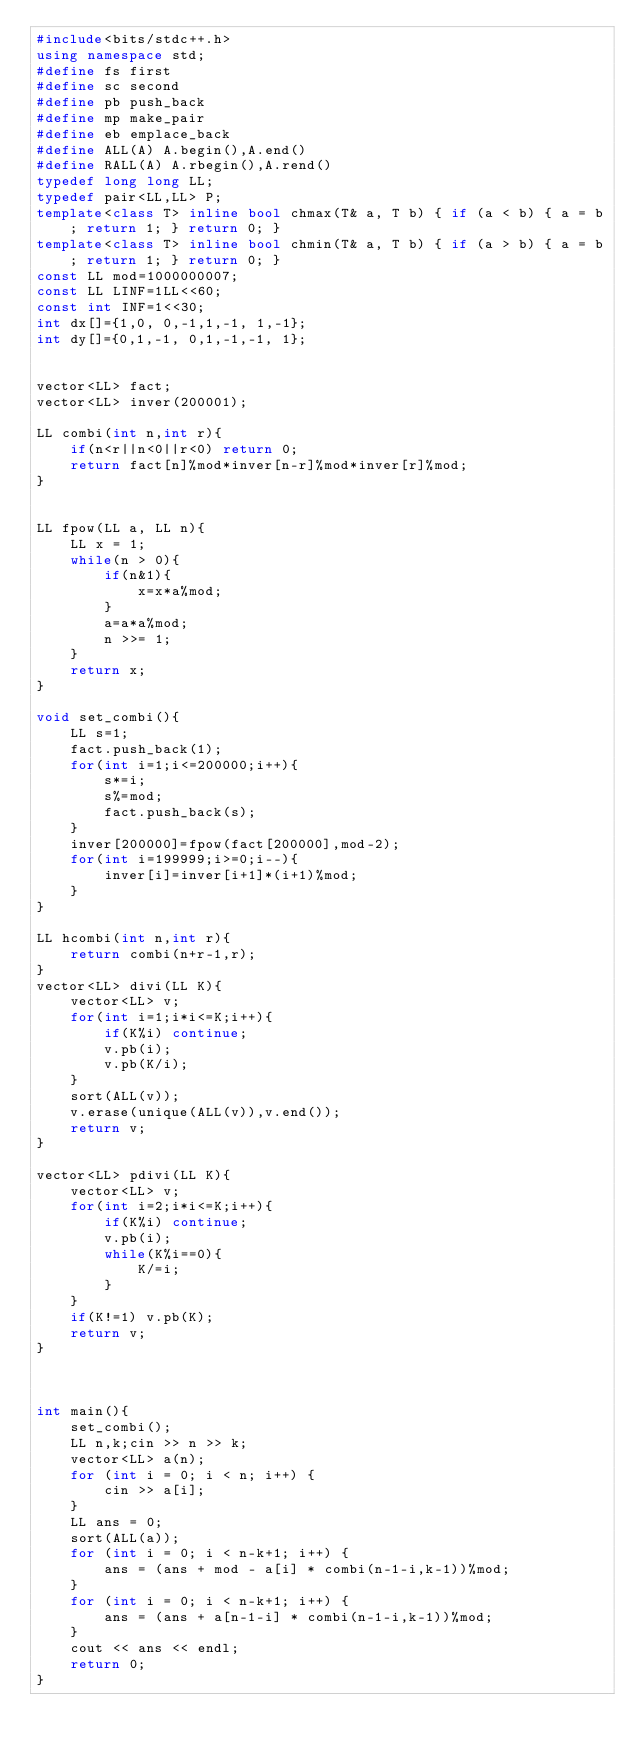<code> <loc_0><loc_0><loc_500><loc_500><_C++_>#include<bits/stdc++.h>
using namespace std;
#define fs first
#define sc second
#define pb push_back
#define mp make_pair
#define eb emplace_back
#define ALL(A) A.begin(),A.end()
#define RALL(A) A.rbegin(),A.rend()
typedef long long LL;
typedef pair<LL,LL> P;
template<class T> inline bool chmax(T& a, T b) { if (a < b) { a = b; return 1; } return 0; }
template<class T> inline bool chmin(T& a, T b) { if (a > b) { a = b; return 1; } return 0; }
const LL mod=1000000007;
const LL LINF=1LL<<60;
const int INF=1<<30;
int dx[]={1,0, 0,-1,1,-1, 1,-1};
int dy[]={0,1,-1, 0,1,-1,-1, 1};

 
vector<LL> fact;
vector<LL> inver(200001);
 
LL combi(int n,int r){
    if(n<r||n<0||r<0) return 0;
    return fact[n]%mod*inver[n-r]%mod*inver[r]%mod;
}
 
 
LL fpow(LL a, LL n){
    LL x = 1;
    while(n > 0){
        if(n&1){
            x=x*a%mod;
        }
        a=a*a%mod;
        n >>= 1;
    }
    return x;
}
 
void set_combi(){
    LL s=1;
    fact.push_back(1);
    for(int i=1;i<=200000;i++){
        s*=i;
        s%=mod;
        fact.push_back(s);
    }
    inver[200000]=fpow(fact[200000],mod-2);
    for(int i=199999;i>=0;i--){
        inver[i]=inver[i+1]*(i+1)%mod;
    }
}
 
LL hcombi(int n,int r){
    return combi(n+r-1,r); 
}
vector<LL> divi(LL K){
    vector<LL> v;
    for(int i=1;i*i<=K;i++){
        if(K%i) continue;
        v.pb(i);
        v.pb(K/i);
    }
    sort(ALL(v));
    v.erase(unique(ALL(v)),v.end());
    return v;
}

vector<LL> pdivi(LL K){
    vector<LL> v;
    for(int i=2;i*i<=K;i++){
        if(K%i) continue;
        v.pb(i);
        while(K%i==0){
            K/=i;
        }
    }
    if(K!=1) v.pb(K);
    return v;
}



int main(){
    set_combi();
    LL n,k;cin >> n >> k;
    vector<LL> a(n);
    for (int i = 0; i < n; i++) {
        cin >> a[i];
    }
    LL ans = 0;
    sort(ALL(a));
    for (int i = 0; i < n-k+1; i++) {
        ans = (ans + mod - a[i] * combi(n-1-i,k-1))%mod;
    }
    for (int i = 0; i < n-k+1; i++) {
        ans = (ans + a[n-1-i] * combi(n-1-i,k-1))%mod;
    }
    cout << ans << endl;
    return 0;
}

</code> 